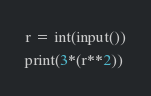Convert code to text. <code><loc_0><loc_0><loc_500><loc_500><_Python_>r = int(input())
print(3*(r**2))</code> 